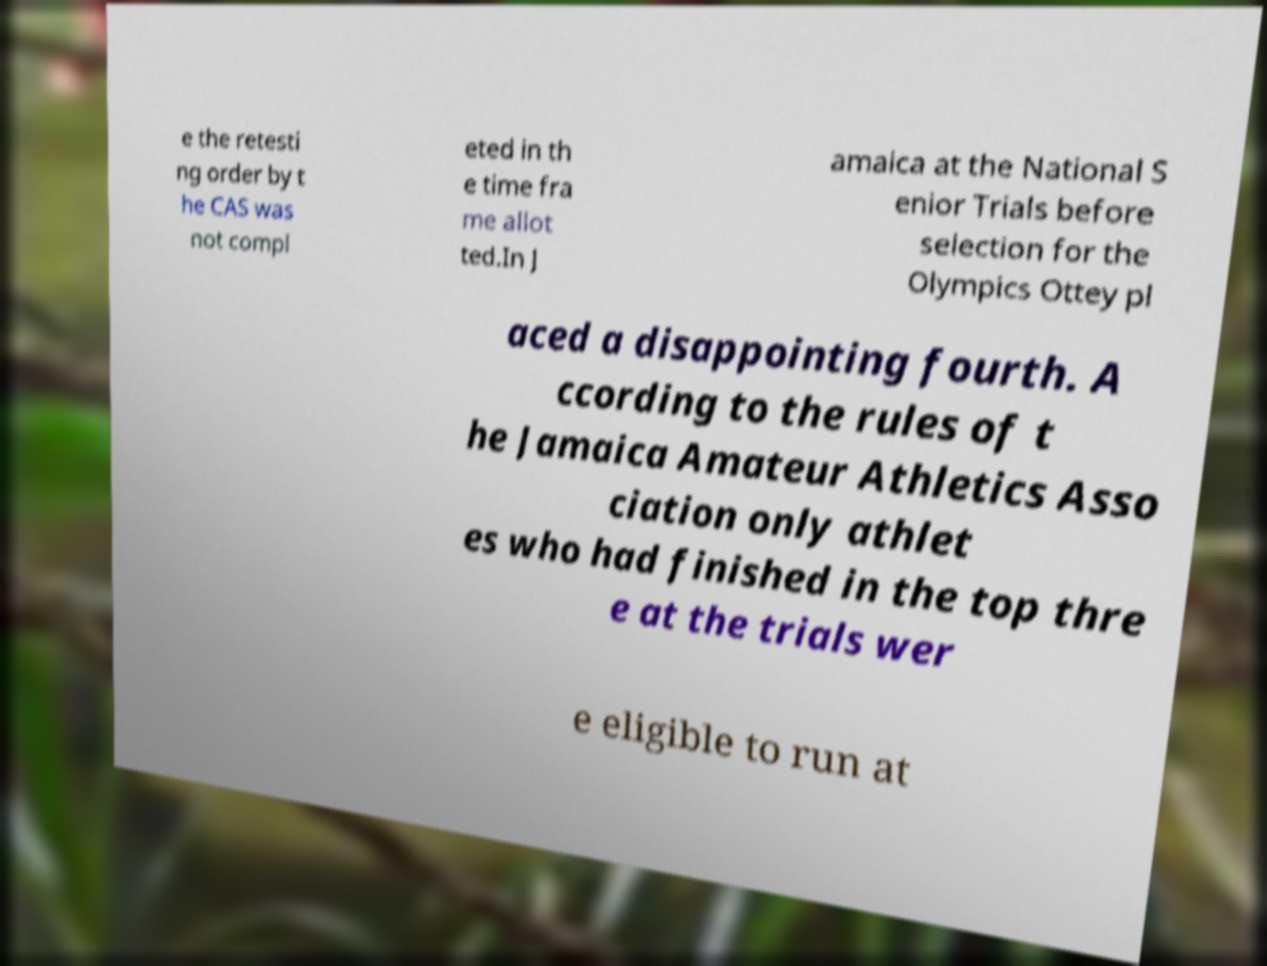Can you read and provide the text displayed in the image?This photo seems to have some interesting text. Can you extract and type it out for me? e the retesti ng order by t he CAS was not compl eted in th e time fra me allot ted.In J amaica at the National S enior Trials before selection for the Olympics Ottey pl aced a disappointing fourth. A ccording to the rules of t he Jamaica Amateur Athletics Asso ciation only athlet es who had finished in the top thre e at the trials wer e eligible to run at 